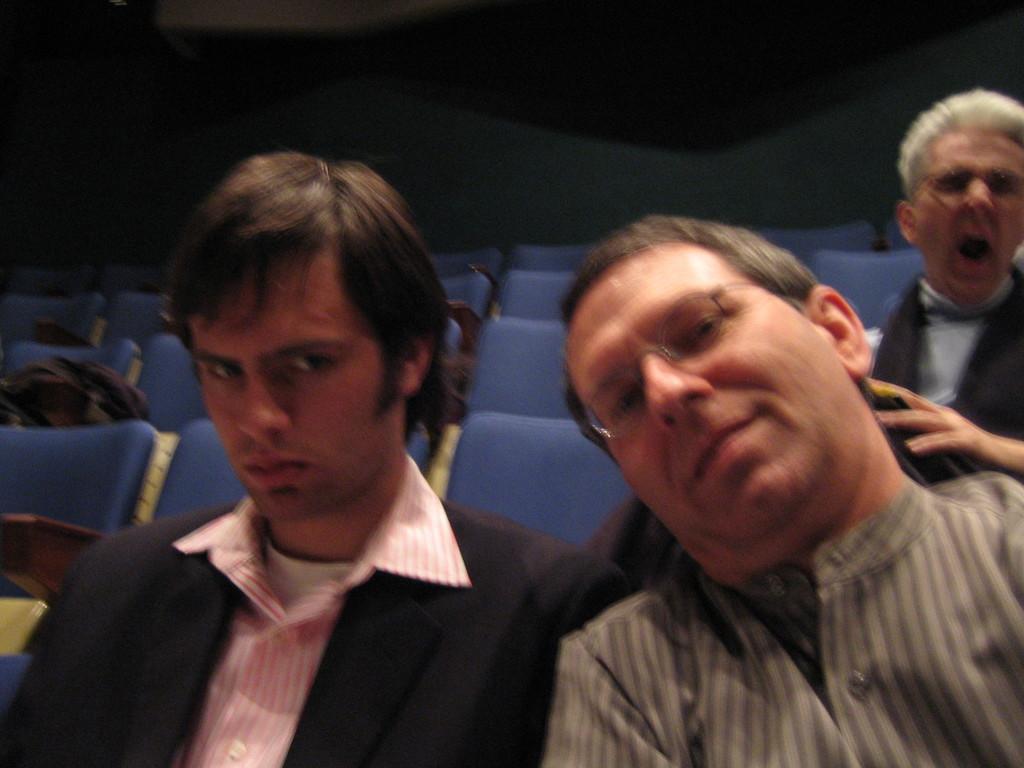Describe this image in one or two sentences. In this picture there is a man who is wearing spectacle and shirt, beside him there is another man who is wearing blazer and pink shirt. Both of them were sitting on the chair. In the top right there is another man who is doing yawning. 